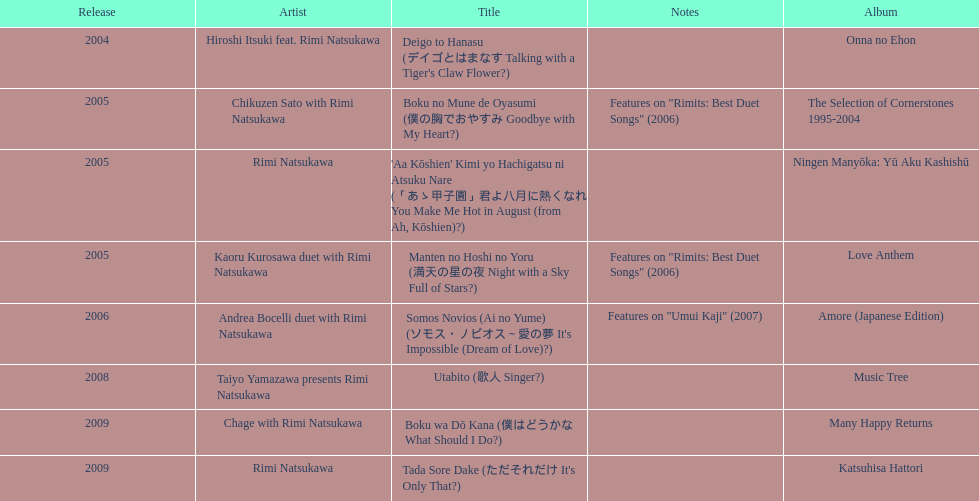During 2005, in how many events did this artist participate other than this one? 3. 